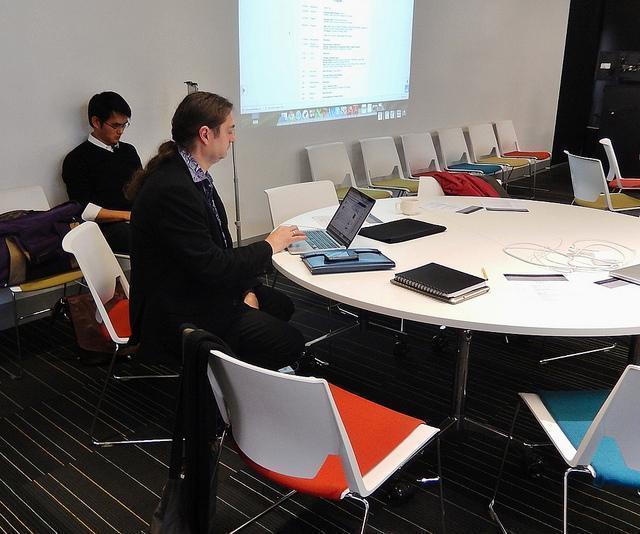What is the operating system being projected?
Make your selection and explain in format: 'Answer: answer
Rationale: rationale.'
Options: Mac os, ms dos, linux, windows. Answer: mac os.
Rationale: The operating system being shown is an apple system. 